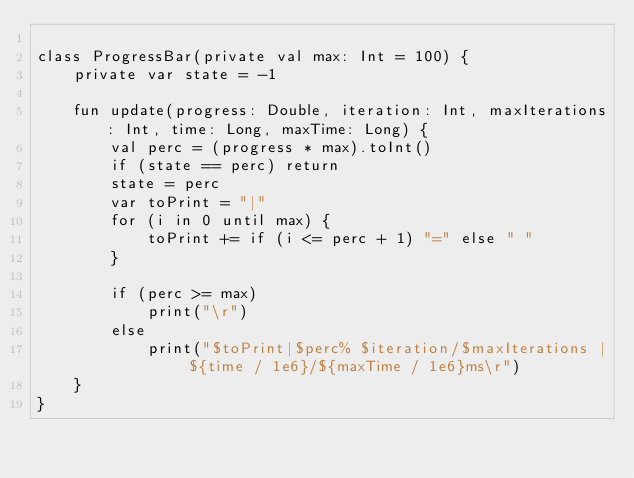<code> <loc_0><loc_0><loc_500><loc_500><_Kotlin_>
class ProgressBar(private val max: Int = 100) {
    private var state = -1

    fun update(progress: Double, iteration: Int, maxIterations: Int, time: Long, maxTime: Long) {
        val perc = (progress * max).toInt()
        if (state == perc) return
        state = perc
        var toPrint = "|"
        for (i in 0 until max) {
            toPrint += if (i <= perc + 1) "=" else " "
        }

        if (perc >= max)
            print("\r")
        else
            print("$toPrint|$perc% $iteration/$maxIterations | ${time / 1e6}/${maxTime / 1e6}ms\r")
    }
}
</code> 